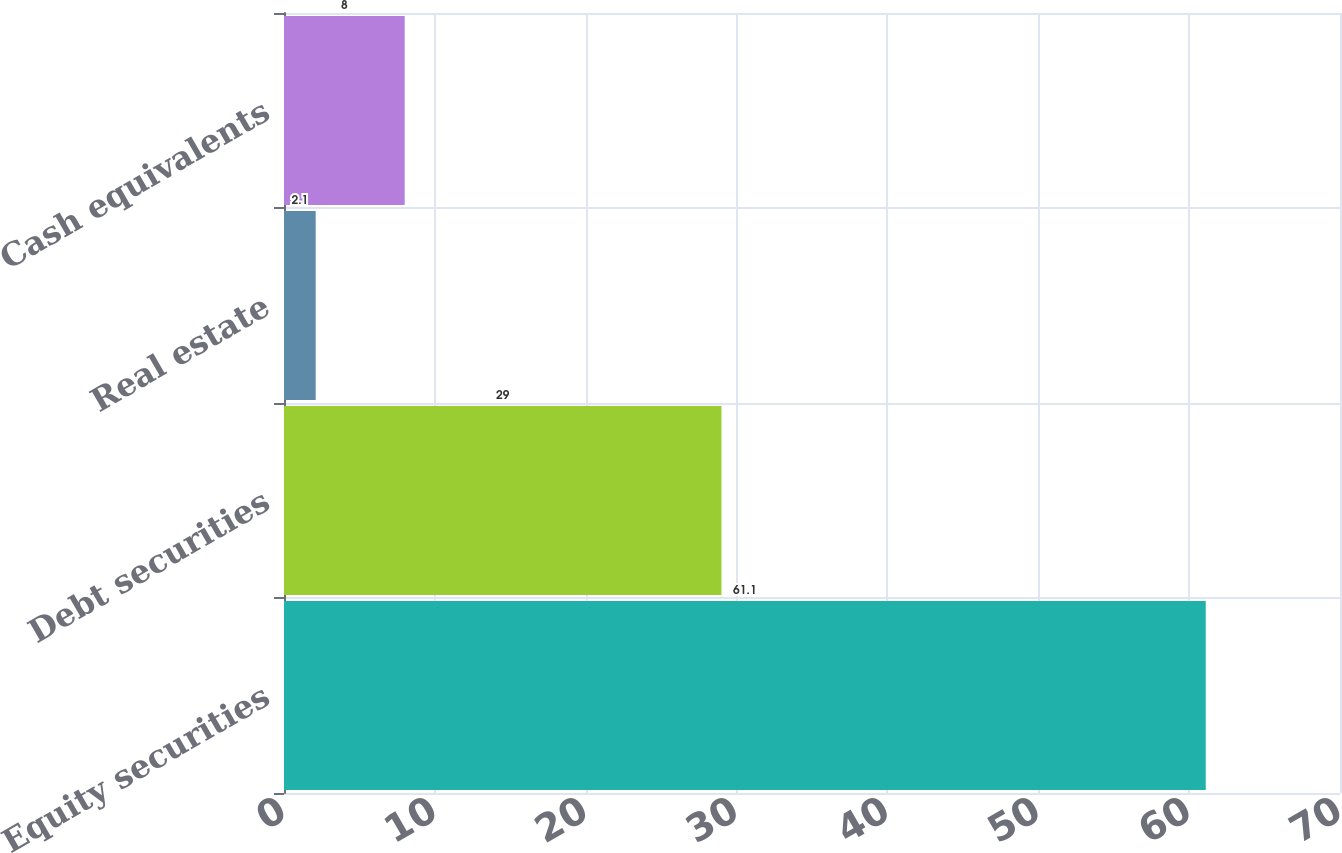Convert chart to OTSL. <chart><loc_0><loc_0><loc_500><loc_500><bar_chart><fcel>Equity securities<fcel>Debt securities<fcel>Real estate<fcel>Cash equivalents<nl><fcel>61.1<fcel>29<fcel>2.1<fcel>8<nl></chart> 